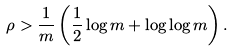<formula> <loc_0><loc_0><loc_500><loc_500>\rho > \frac { 1 } { m } \left ( \frac { 1 } { 2 } \log m + \log \log m \right ) .</formula> 